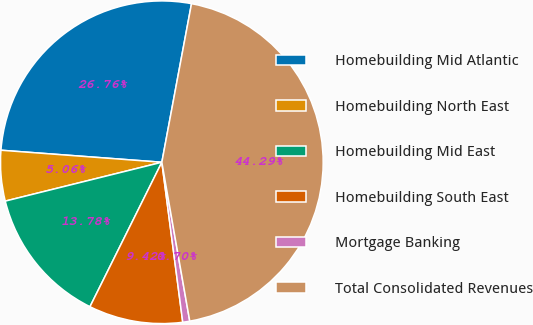<chart> <loc_0><loc_0><loc_500><loc_500><pie_chart><fcel>Homebuilding Mid Atlantic<fcel>Homebuilding North East<fcel>Homebuilding Mid East<fcel>Homebuilding South East<fcel>Mortgage Banking<fcel>Total Consolidated Revenues<nl><fcel>26.76%<fcel>5.06%<fcel>13.78%<fcel>9.42%<fcel>0.7%<fcel>44.29%<nl></chart> 